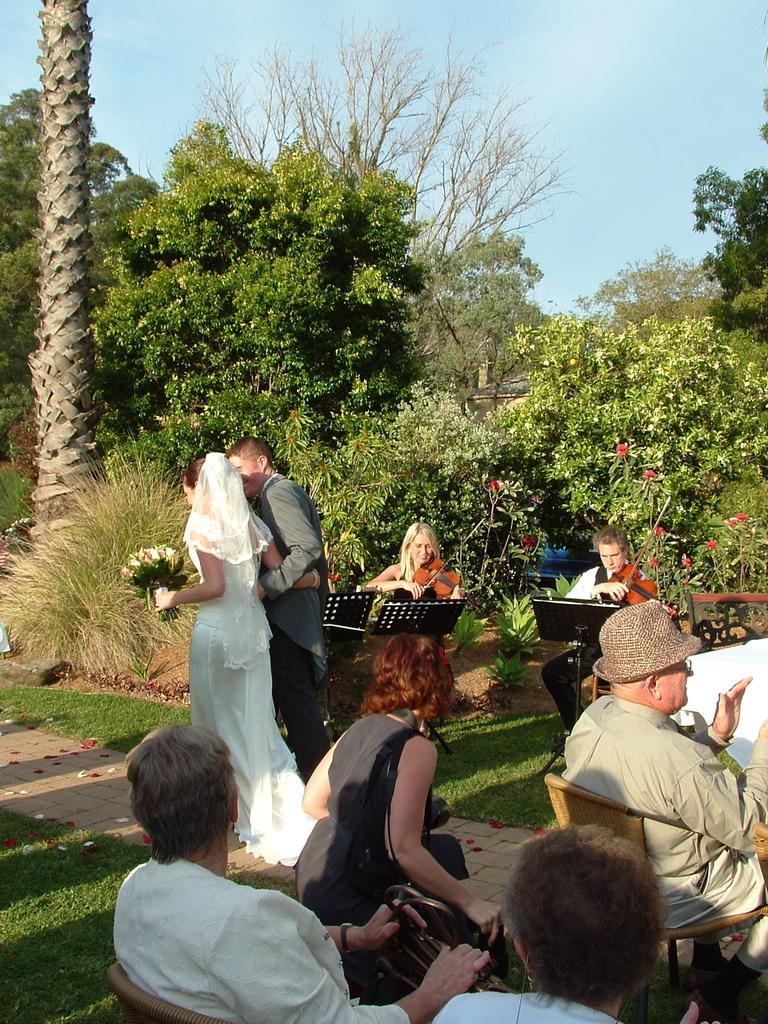In one or two sentences, can you explain what this image depicts? Here we can see few persons and they are sitting on the chairs. Here we can see grass, plants, flowers, and trees. In the background there is sky. 